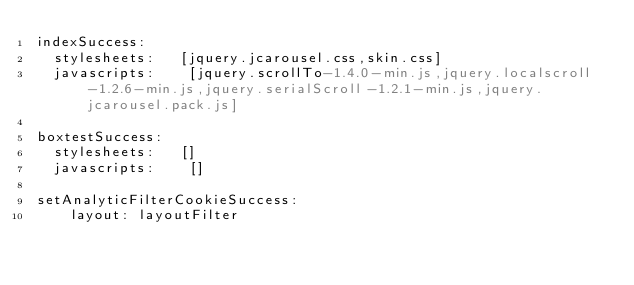<code> <loc_0><loc_0><loc_500><loc_500><_YAML_>indexSuccess:
  stylesheets:   [jquery.jcarousel.css,skin.css]
  javascripts:    [jquery.scrollTo-1.4.0-min.js,jquery.localscroll-1.2.6-min.js,jquery.serialScroll-1.2.1-min.js,jquery.jcarousel.pack.js]

boxtestSuccess:
  stylesheets:   []
  javascripts:    []

setAnalyticFilterCookieSuccess:
    layout: layoutFilter</code> 